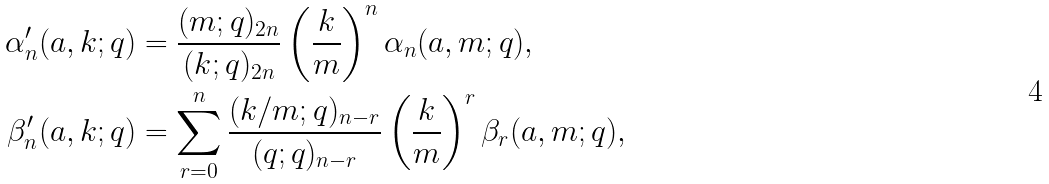Convert formula to latex. <formula><loc_0><loc_0><loc_500><loc_500>\alpha ^ { \prime } _ { n } ( a , k ; q ) & = \frac { ( m ; q ) _ { 2 n } } { ( k ; q ) _ { 2 n } } \left ( \frac { k } { m } \right ) ^ { n } \alpha _ { n } ( a , m ; q ) , \\ \beta ^ { \prime } _ { n } ( a , k ; q ) & = \sum _ { r = 0 } ^ { n } \frac { ( k / m ; q ) _ { n - r } } { ( q ; q ) _ { n - r } } \left ( \frac { k } { m } \right ) ^ { r } \beta _ { r } ( a , m ; q ) ,</formula> 